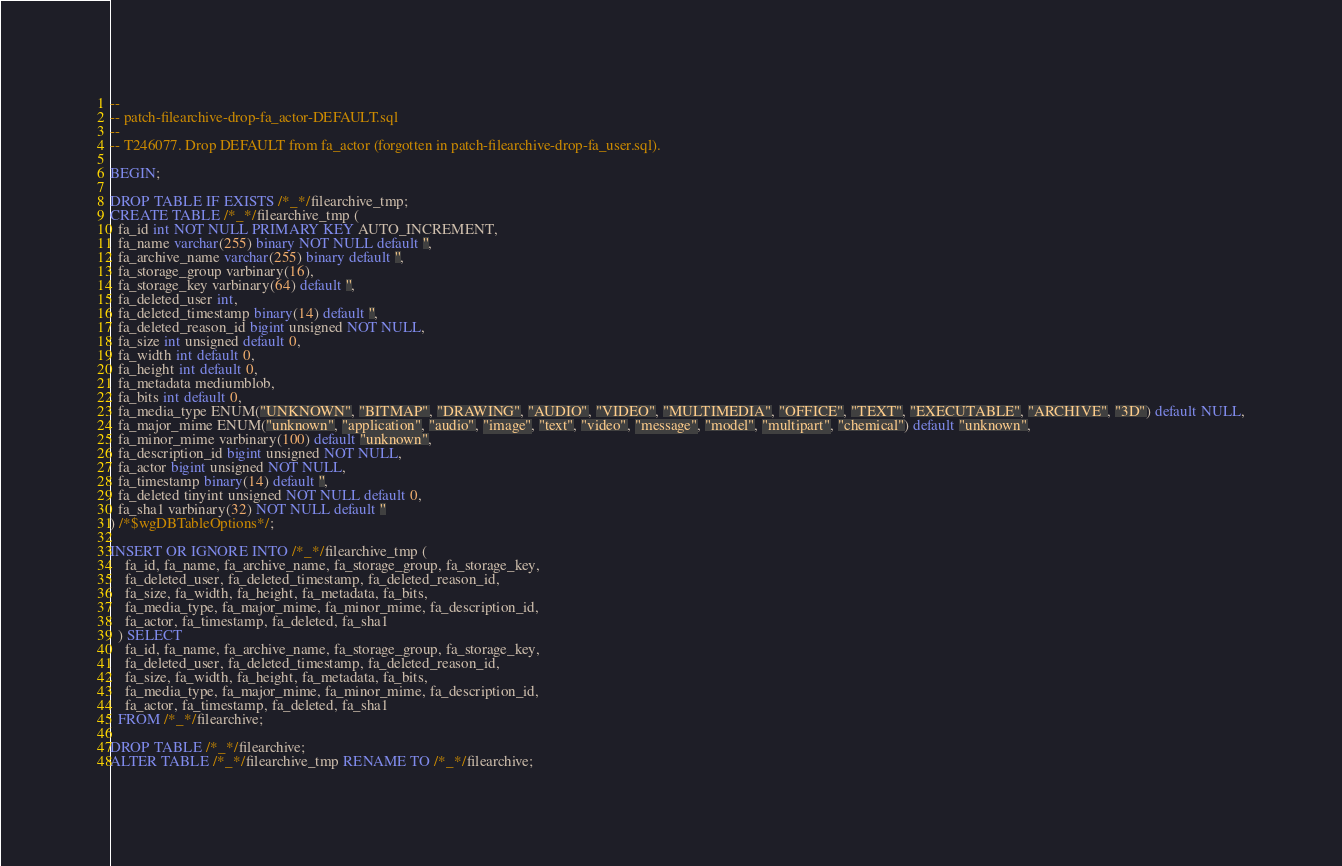<code> <loc_0><loc_0><loc_500><loc_500><_SQL_>--
-- patch-filearchive-drop-fa_actor-DEFAULT.sql
--
-- T246077. Drop DEFAULT from fa_actor (forgotten in patch-filearchive-drop-fa_user.sql).

BEGIN;

DROP TABLE IF EXISTS /*_*/filearchive_tmp;
CREATE TABLE /*_*/filearchive_tmp (
  fa_id int NOT NULL PRIMARY KEY AUTO_INCREMENT,
  fa_name varchar(255) binary NOT NULL default '',
  fa_archive_name varchar(255) binary default '',
  fa_storage_group varbinary(16),
  fa_storage_key varbinary(64) default '',
  fa_deleted_user int,
  fa_deleted_timestamp binary(14) default '',
  fa_deleted_reason_id bigint unsigned NOT NULL,
  fa_size int unsigned default 0,
  fa_width int default 0,
  fa_height int default 0,
  fa_metadata mediumblob,
  fa_bits int default 0,
  fa_media_type ENUM("UNKNOWN", "BITMAP", "DRAWING", "AUDIO", "VIDEO", "MULTIMEDIA", "OFFICE", "TEXT", "EXECUTABLE", "ARCHIVE", "3D") default NULL,
  fa_major_mime ENUM("unknown", "application", "audio", "image", "text", "video", "message", "model", "multipart", "chemical") default "unknown",
  fa_minor_mime varbinary(100) default "unknown",
  fa_description_id bigint unsigned NOT NULL,
  fa_actor bigint unsigned NOT NULL,
  fa_timestamp binary(14) default '',
  fa_deleted tinyint unsigned NOT NULL default 0,
  fa_sha1 varbinary(32) NOT NULL default ''
) /*$wgDBTableOptions*/;

INSERT OR IGNORE INTO /*_*/filearchive_tmp (
	fa_id, fa_name, fa_archive_name, fa_storage_group, fa_storage_key,
	fa_deleted_user, fa_deleted_timestamp, fa_deleted_reason_id,
	fa_size, fa_width, fa_height, fa_metadata, fa_bits,
	fa_media_type, fa_major_mime, fa_minor_mime, fa_description_id,
	fa_actor, fa_timestamp, fa_deleted, fa_sha1
  ) SELECT
	fa_id, fa_name, fa_archive_name, fa_storage_group, fa_storage_key,
	fa_deleted_user, fa_deleted_timestamp, fa_deleted_reason_id,
	fa_size, fa_width, fa_height, fa_metadata, fa_bits,
	fa_media_type, fa_major_mime, fa_minor_mime, fa_description_id,
	fa_actor, fa_timestamp, fa_deleted, fa_sha1
  FROM /*_*/filearchive;

DROP TABLE /*_*/filearchive;
ALTER TABLE /*_*/filearchive_tmp RENAME TO /*_*/filearchive;</code> 